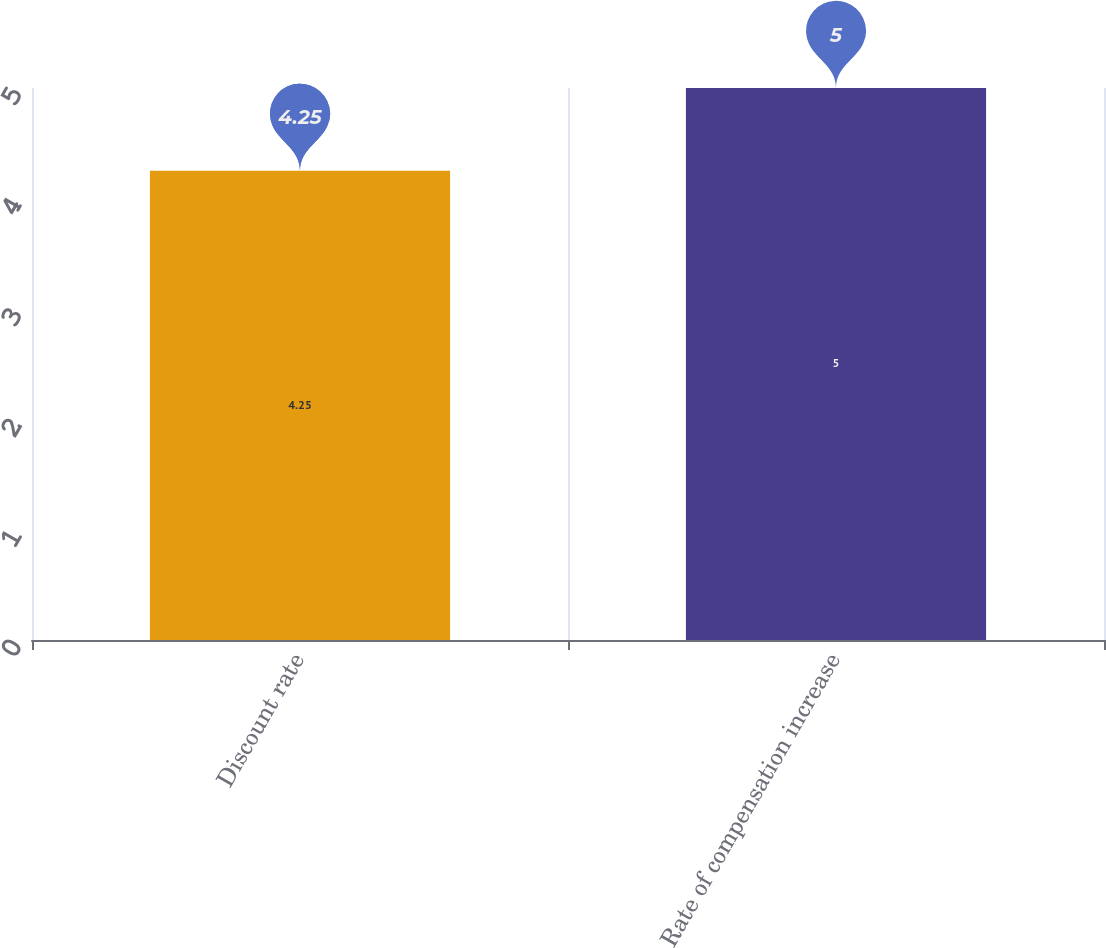Convert chart. <chart><loc_0><loc_0><loc_500><loc_500><bar_chart><fcel>Discount rate<fcel>Rate of compensation increase<nl><fcel>4.25<fcel>5<nl></chart> 